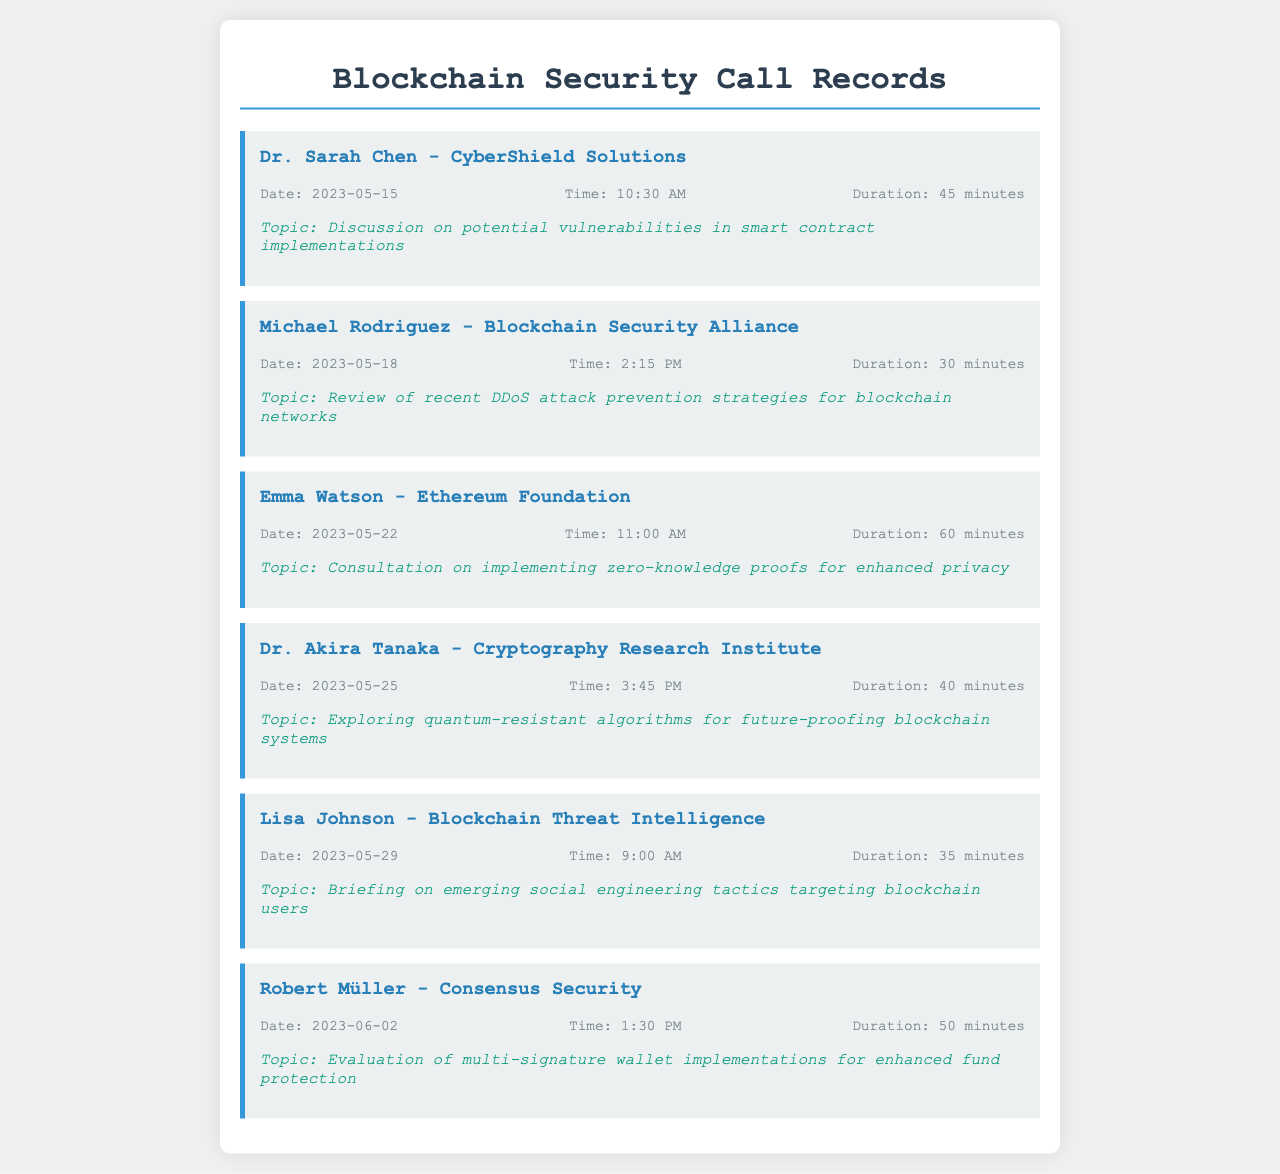What is the name of the first person called? The first person mentioned in the call records is Dr. Sarah Chen from CyberShield Solutions.
Answer: Dr. Sarah Chen What was the duration of the call with Michael Rodriguez? The duration of the call with Michael Rodriguez was 30 minutes.
Answer: 30 minutes On which date was the call with Emma Watson made? The call with Emma Watson took place on May 22, 2023.
Answer: May 22, 2023 What is the topic discussed with Dr. Akira Tanaka? The topic discussed with Dr. Akira Tanaka was exploring quantum-resistant algorithms for future-proofing blockchain systems.
Answer: Exploring quantum-resistant algorithms for future-proofing blockchain systems How many minutes was the call with Lisa Johnson? The call with Lisa Johnson lasted for 35 minutes.
Answer: 35 minutes Which organization is Robert Müller associated with? Robert Müller is associated with Consensus Security.
Answer: Consensus Security What was the primary focus of the call on May 25? The primary focus of the May 25 call was exploring quantum-resistant algorithms for future-proofing blockchain systems.
Answer: Exploring quantum-resistant algorithms for future-proofing blockchain systems Which expert discussed social engineering tactics? Lisa Johnson discussed emerging social engineering tactics targeting blockchain users.
Answer: Lisa Johnson How many calls are recorded in total? There are six calls recorded in total in the document.
Answer: Six 